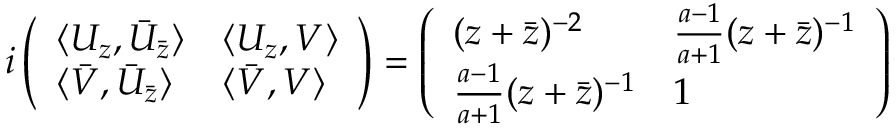Convert formula to latex. <formula><loc_0><loc_0><loc_500><loc_500>i \left ( \begin{array} { l l } { { \langle U _ { z } , \bar { U } _ { \bar { z } } \rangle } } & { { \langle U _ { z } , V \rangle } } \\ { { \langle \bar { V } , \bar { U } _ { \bar { z } } \rangle } } & { { \langle \bar { V } , V \rangle } } \end{array} \right ) = \left ( \begin{array} { l l } { { ( z + \bar { z } ) ^ { - 2 } } } & { { \frac { a - 1 } { a + 1 } ( z + \bar { z } ) ^ { - 1 } } } \\ { { \frac { a - 1 } { a + 1 } ( z + \bar { z } ) ^ { - 1 } } } & { 1 } \end{array} \right )</formula> 